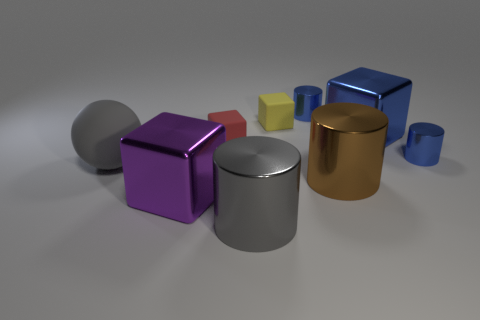Subtract all brown cylinders. How many cylinders are left? 3 Add 1 cyan metallic things. How many objects exist? 10 Subtract all blue cylinders. How many cylinders are left? 2 Subtract all cubes. How many objects are left? 5 Subtract 3 cylinders. How many cylinders are left? 1 Subtract all red cylinders. Subtract all brown balls. How many cylinders are left? 4 Subtract all blue balls. How many blue cylinders are left? 2 Subtract all big blue blocks. Subtract all large blue shiny blocks. How many objects are left? 7 Add 3 big cubes. How many big cubes are left? 5 Add 7 large metal blocks. How many large metal blocks exist? 9 